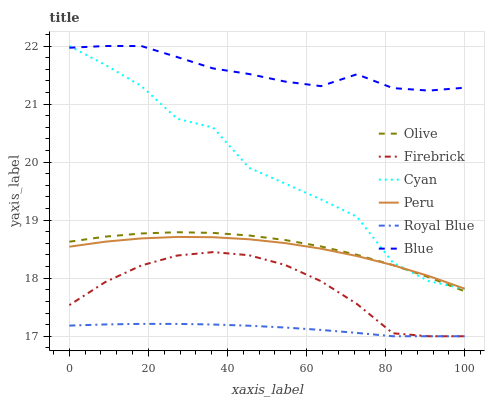Does Royal Blue have the minimum area under the curve?
Answer yes or no. Yes. Does Blue have the maximum area under the curve?
Answer yes or no. Yes. Does Firebrick have the minimum area under the curve?
Answer yes or no. No. Does Firebrick have the maximum area under the curve?
Answer yes or no. No. Is Royal Blue the smoothest?
Answer yes or no. Yes. Is Cyan the roughest?
Answer yes or no. Yes. Is Firebrick the smoothest?
Answer yes or no. No. Is Firebrick the roughest?
Answer yes or no. No. Does Firebrick have the lowest value?
Answer yes or no. Yes. Does Peru have the lowest value?
Answer yes or no. No. Does Cyan have the highest value?
Answer yes or no. Yes. Does Firebrick have the highest value?
Answer yes or no. No. Is Firebrick less than Cyan?
Answer yes or no. Yes. Is Olive greater than Royal Blue?
Answer yes or no. Yes. Does Cyan intersect Olive?
Answer yes or no. Yes. Is Cyan less than Olive?
Answer yes or no. No. Is Cyan greater than Olive?
Answer yes or no. No. Does Firebrick intersect Cyan?
Answer yes or no. No. 